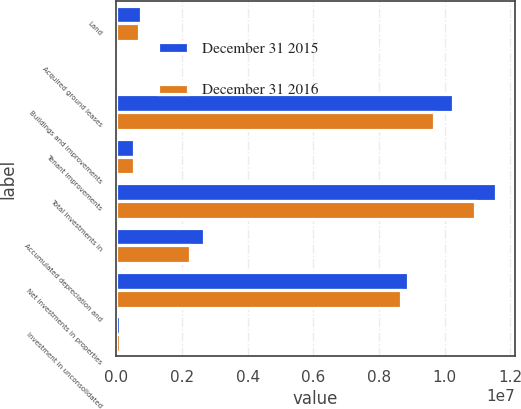Convert chart to OTSL. <chart><loc_0><loc_0><loc_500><loc_500><stacked_bar_chart><ecel><fcel>Land<fcel>Acquired ground leases<fcel>Buildings and improvements<fcel>Tenant improvements<fcel>Total investments in<fcel>Accumulated depreciation and<fcel>Net investments in properties<fcel>Investment in unconsolidated<nl><fcel>December 31 2015<fcel>746822<fcel>11335<fcel>1.02675e+07<fcel>532787<fcel>1.15585e+07<fcel>2.66851e+06<fcel>8.88996e+06<fcel>106402<nl><fcel>December 31 2016<fcel>689573<fcel>12639<fcel>9.67643e+06<fcel>536734<fcel>1.09154e+07<fcel>2.25127e+06<fcel>8.6641e+06<fcel>106107<nl></chart> 